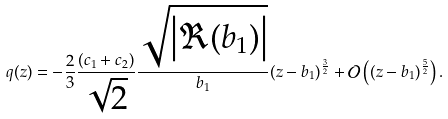<formula> <loc_0><loc_0><loc_500><loc_500>q ( z ) = - \frac { 2 } { 3 } \frac { ( c _ { 1 } + c _ { 2 } ) } { \sqrt { 2 } } \frac { \sqrt { \left | \Re ( b _ { 1 } ) \right | } } { b _ { 1 } } ( z - b _ { 1 } ) ^ { \frac { 3 } { 2 } } + \mathcal { O } \left ( ( z - b _ { 1 } ) ^ { \frac { 5 } { 2 } } \right ) .</formula> 